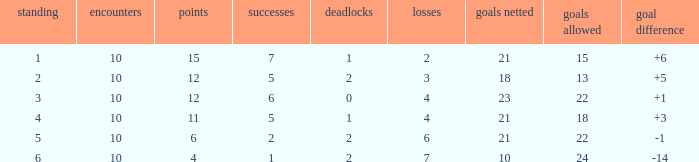Can you tell me the total number of Wins that has the Draws larger than 0, and the Points of 11? 1.0. 